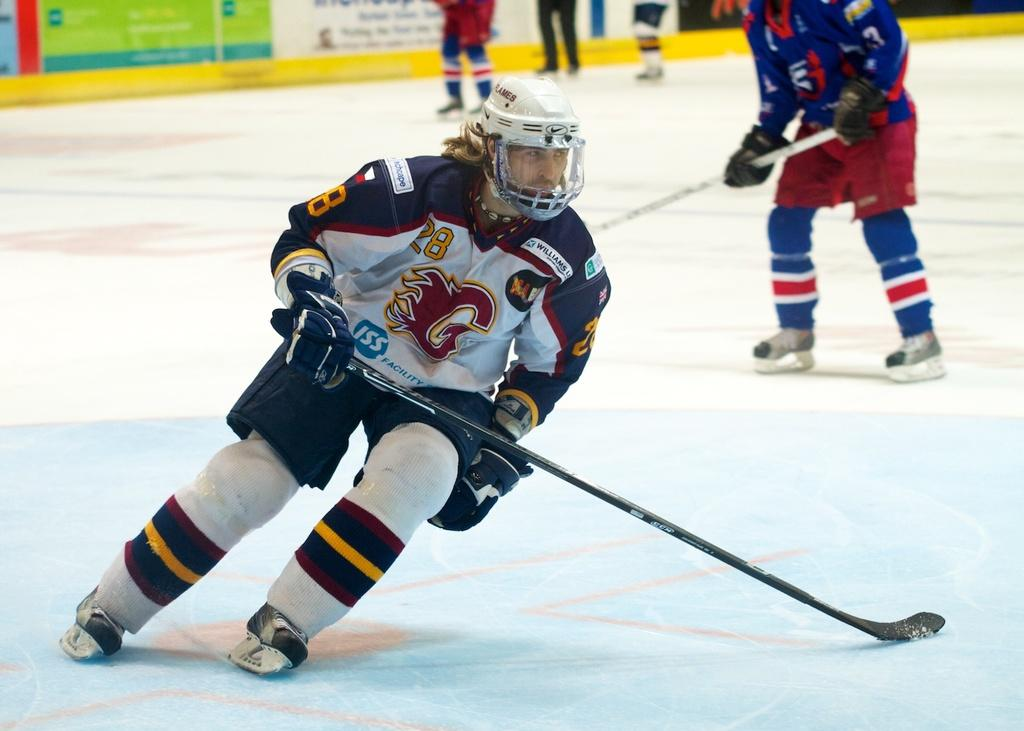How many people are in the image? There are two persons in the image. What are the persons wearing? The persons are wearing colorful dresses. What are the persons holding in their hands? The persons are holding sticks. Can you describe any other visible body parts of the persons in the image? There are visible legs of a person at the top of the image. What type of throat-singing can be heard in the image? There is no sound or indication of throat-singing in the image. Are there any bells attached to the sticks the persons are holding? The provided facts do not mention any bells attached to the sticks. Can you see a duck in the image? There is no duck present in the image. 